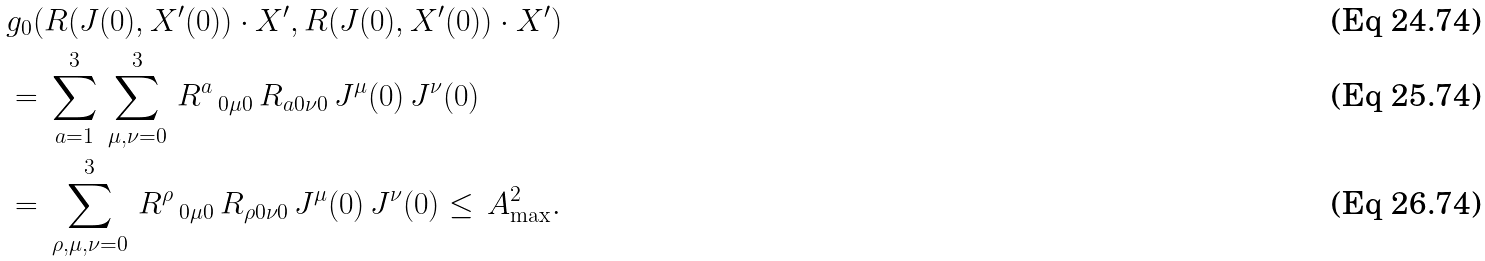Convert formula to latex. <formula><loc_0><loc_0><loc_500><loc_500>& g _ { 0 } ( R ( J ( 0 ) , X ^ { \prime } ( 0 ) ) \cdot X ^ { \prime } , R ( J ( 0 ) , X ^ { \prime } ( 0 ) ) \cdot X ^ { \prime } ) \\ & = \, \sum ^ { 3 } _ { a = 1 } \, \sum ^ { 3 } _ { \mu , \nu = 0 } \, R ^ { a } \, _ { 0 \mu 0 } \, R _ { a 0 \nu 0 } \, J ^ { \mu } ( 0 ) \, J ^ { \nu } ( 0 ) \\ & = \, \sum ^ { 3 } _ { \rho , \mu , \nu = 0 } \, R ^ { \rho } \, _ { 0 \mu 0 } \, R _ { \rho 0 \nu 0 } \, J ^ { \mu } ( 0 ) \, J ^ { \nu } ( 0 ) \leq \, A ^ { 2 } _ { \max } .</formula> 